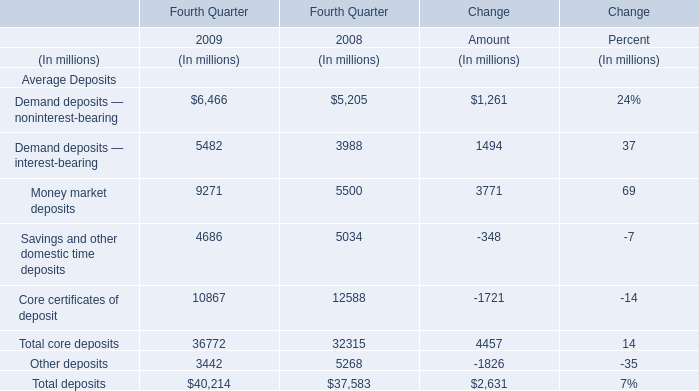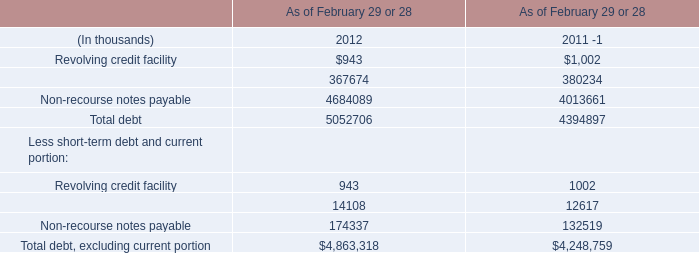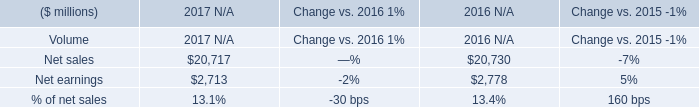What is the ratio of Demand deposits — noninterest-bearing to the total in 2009? 
Computations: (6466 / 40214)
Answer: 0.16079. 